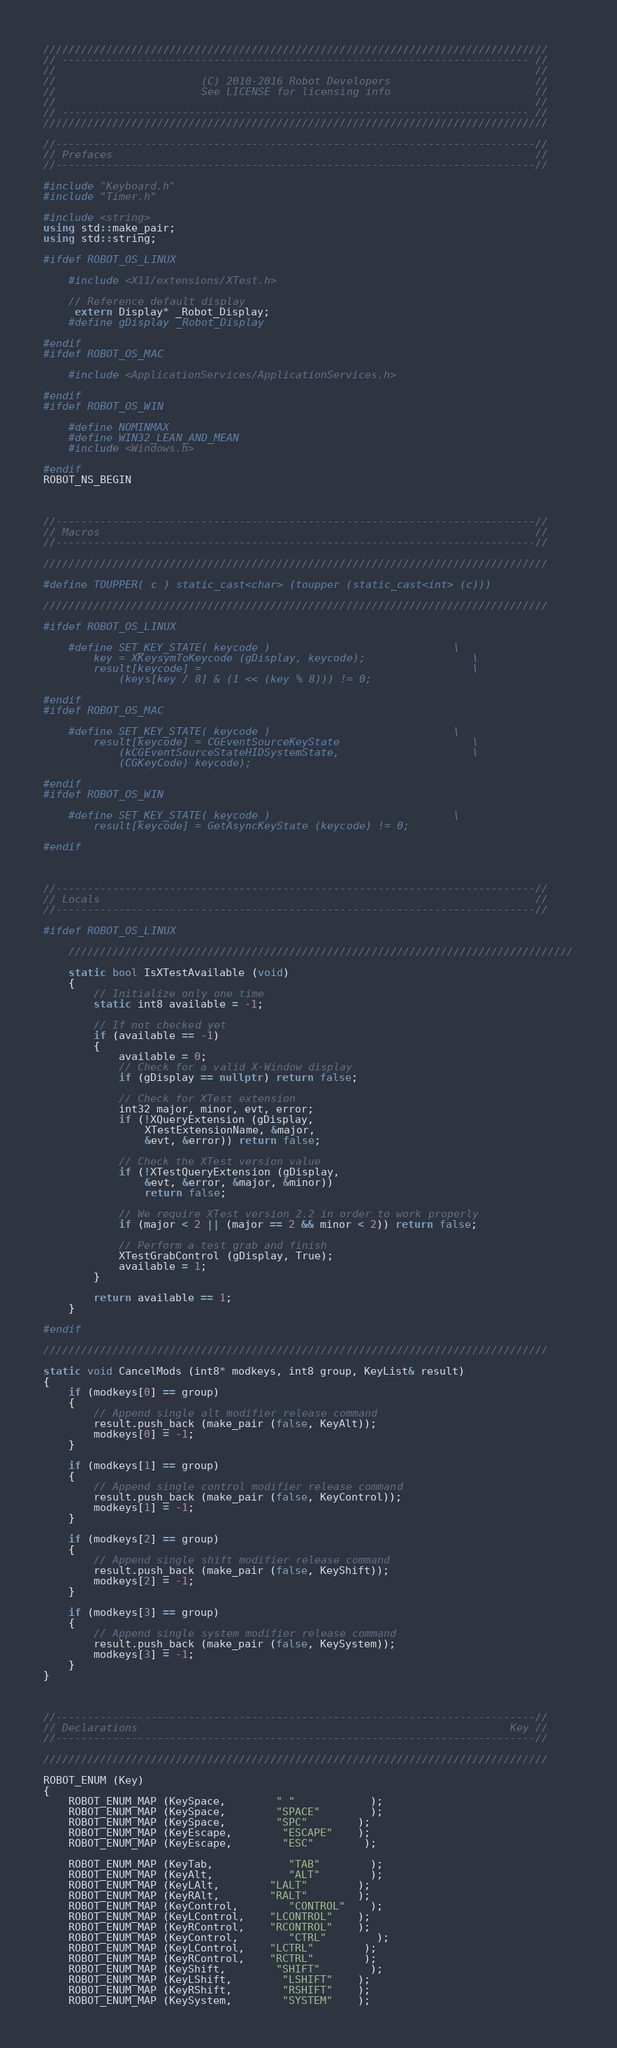Convert code to text. <code><loc_0><loc_0><loc_500><loc_500><_C++_>////////////////////////////////////////////////////////////////////////////////
// -------------------------------------------------------------------------- //
//                                                                            //
//                       (C) 2010-2016 Robot Developers                       //
//                       See LICENSE for licensing info                       //
//                                                                            //
// -------------------------------------------------------------------------- //
////////////////////////////////////////////////////////////////////////////////

//----------------------------------------------------------------------------//
// Prefaces                                                                   //
//----------------------------------------------------------------------------//

#include "Keyboard.h"
#include "Timer.h"

#include <string>
using std::make_pair;
using std::string;

#ifdef ROBOT_OS_LINUX

	#include <X11/extensions/XTest.h>

	// Reference default display
	 extern Display* _Robot_Display;
	#define gDisplay _Robot_Display

#endif
#ifdef ROBOT_OS_MAC

	#include <ApplicationServices/ApplicationServices.h>

#endif
#ifdef ROBOT_OS_WIN

	#define NOMINMAX
	#define WIN32_LEAN_AND_MEAN
	#include <Windows.h>

#endif
ROBOT_NS_BEGIN



//----------------------------------------------------------------------------//
// Macros                                                                     //
//----------------------------------------------------------------------------//

////////////////////////////////////////////////////////////////////////////////

#define TOUPPER( c ) static_cast<char> (toupper (static_cast<int> (c)))

////////////////////////////////////////////////////////////////////////////////

#ifdef ROBOT_OS_LINUX

	#define SET_KEY_STATE( keycode )								\
		key = XKeysymToKeycode (gDisplay, keycode);					\
		result[keycode] =											\
			(keys[key / 8] & (1 << (key % 8))) != 0;

#endif
#ifdef ROBOT_OS_MAC

	#define SET_KEY_STATE( keycode )								\
		result[keycode] = CGEventSourceKeyState						\
			(kCGEventSourceStateHIDSystemState,						\
			(CGKeyCode) keycode);

#endif
#ifdef ROBOT_OS_WIN

	#define SET_KEY_STATE( keycode )								\
		result[keycode] = GetAsyncKeyState (keycode) != 0;

#endif



//----------------------------------------------------------------------------//
// Locals                                                                     //
//----------------------------------------------------------------------------//

#ifdef ROBOT_OS_LINUX

	////////////////////////////////////////////////////////////////////////////////

	static bool IsXTestAvailable (void)
	{
		// Initialize only one time
		static int8 available = -1;

		// If not checked yet
		if (available == -1)
		{
			available = 0;
			// Check for a valid X-Window display
			if (gDisplay == nullptr) return false;

			// Check for XTest extension
			int32 major, minor, evt, error;
			if (!XQueryExtension (gDisplay,
				XTestExtensionName, &major,
				&evt, &error)) return false;

			// Check the XTest version value
			if (!XTestQueryExtension (gDisplay,
				&evt, &error, &major, &minor))
				return false;

			// We require XTest version 2.2 in order to work properly
			if (major < 2 || (major == 2 && minor < 2)) return false;

			// Perform a test grab and finish
			XTestGrabControl (gDisplay, True);
			available = 1;
		}

		return available == 1;
	}

#endif

////////////////////////////////////////////////////////////////////////////////

static void CancelMods (int8* modkeys, int8 group, KeyList& result)
{
	if (modkeys[0] == group)
	{
		// Append single alt modifier release command
		result.push_back (make_pair (false, KeyAlt));
		modkeys[0] = -1;
	}

	if (modkeys[1] == group)
	{
		// Append single control modifier release command
		result.push_back (make_pair (false, KeyControl));
		modkeys[1] = -1;
	}

	if (modkeys[2] == group)
	{
		// Append single shift modifier release command
		result.push_back (make_pair (false, KeyShift));
		modkeys[2] = -1;
	}

	if (modkeys[3] == group)
	{
		// Append single system modifier release command
		result.push_back (make_pair (false, KeySystem));
		modkeys[3] = -1;
	}
}



//----------------------------------------------------------------------------//
// Declarations                                                           Key //
//----------------------------------------------------------------------------//

////////////////////////////////////////////////////////////////////////////////

ROBOT_ENUM (Key)
{
	ROBOT_ENUM_MAP (KeySpace,		" "			);
	ROBOT_ENUM_MAP (KeySpace,		"SPACE"		);
	ROBOT_ENUM_MAP (KeySpace,		"SPC"		);
	ROBOT_ENUM_MAP (KeyEscape,		"ESCAPE"	);
	ROBOT_ENUM_MAP (KeyEscape,		"ESC"		);

	ROBOT_ENUM_MAP (KeyTab,			"TAB"		);
	ROBOT_ENUM_MAP (KeyAlt,			"ALT"		);
	ROBOT_ENUM_MAP (KeyLAlt,		"LALT"		);
	ROBOT_ENUM_MAP (KeyRAlt,		"RALT"		);
	ROBOT_ENUM_MAP (KeyControl,		"CONTROL"	);
	ROBOT_ENUM_MAP (KeyLControl,	"LCONTROL"	);
	ROBOT_ENUM_MAP (KeyRControl,	"RCONTROL"	);
	ROBOT_ENUM_MAP (KeyControl,		"CTRL"		);
	ROBOT_ENUM_MAP (KeyLControl,	"LCTRL"		);
	ROBOT_ENUM_MAP (KeyRControl,	"RCTRL"		);
	ROBOT_ENUM_MAP (KeyShift,		"SHIFT"		);
	ROBOT_ENUM_MAP (KeyLShift,		"LSHIFT"	);
	ROBOT_ENUM_MAP (KeyRShift,		"RSHIFT"	);
	ROBOT_ENUM_MAP (KeySystem,		"SYSTEM"	);</code> 